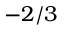<formula> <loc_0><loc_0><loc_500><loc_500>- 2 / 3</formula> 